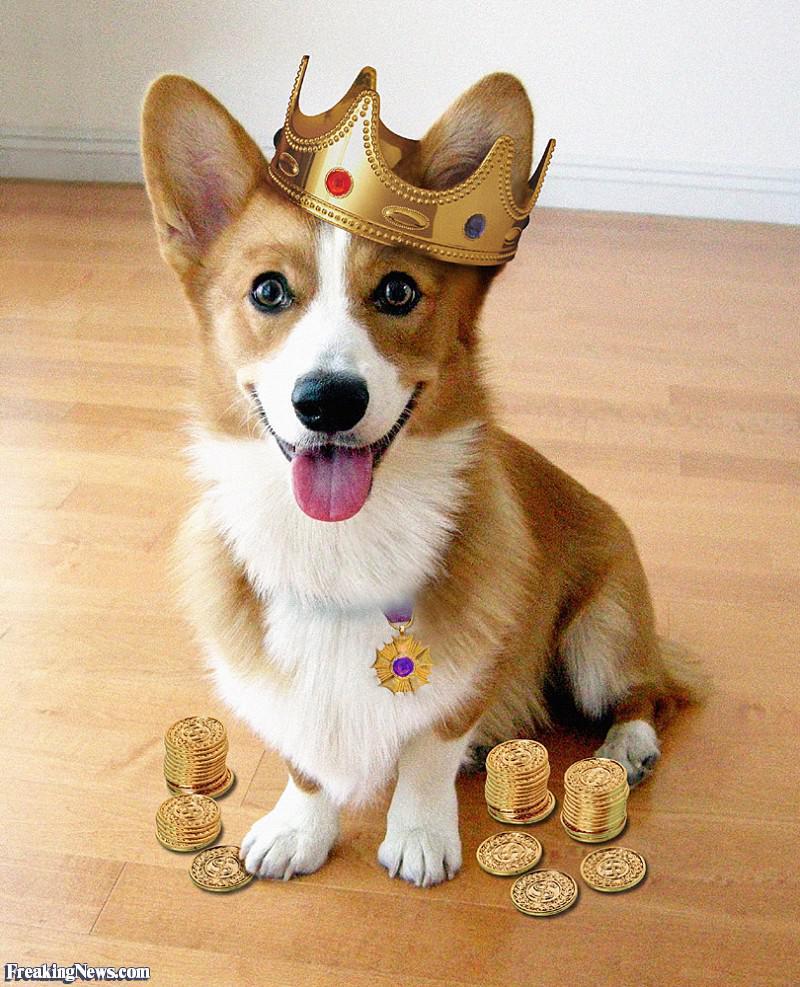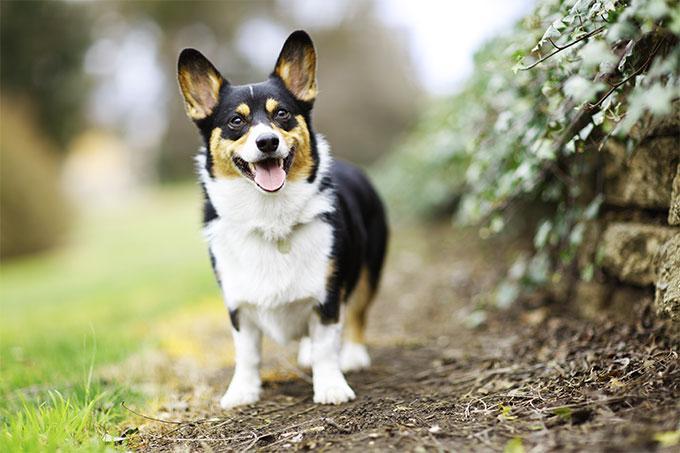The first image is the image on the left, the second image is the image on the right. Considering the images on both sides, is "One of the dogs is wearing a collar with no charms." valid? Answer yes or no. No. 